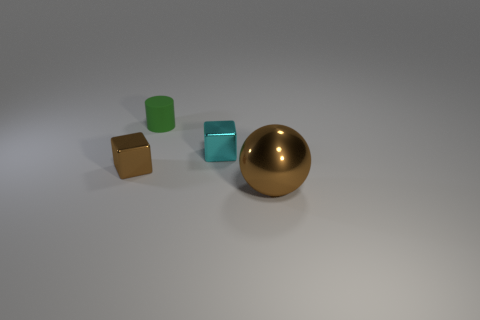Add 3 large brown shiny objects. How many objects exist? 7 Subtract all balls. How many objects are left? 3 Subtract all rubber cylinders. Subtract all big balls. How many objects are left? 2 Add 1 green things. How many green things are left? 2 Add 1 big yellow rubber objects. How many big yellow rubber objects exist? 1 Subtract 0 green balls. How many objects are left? 4 